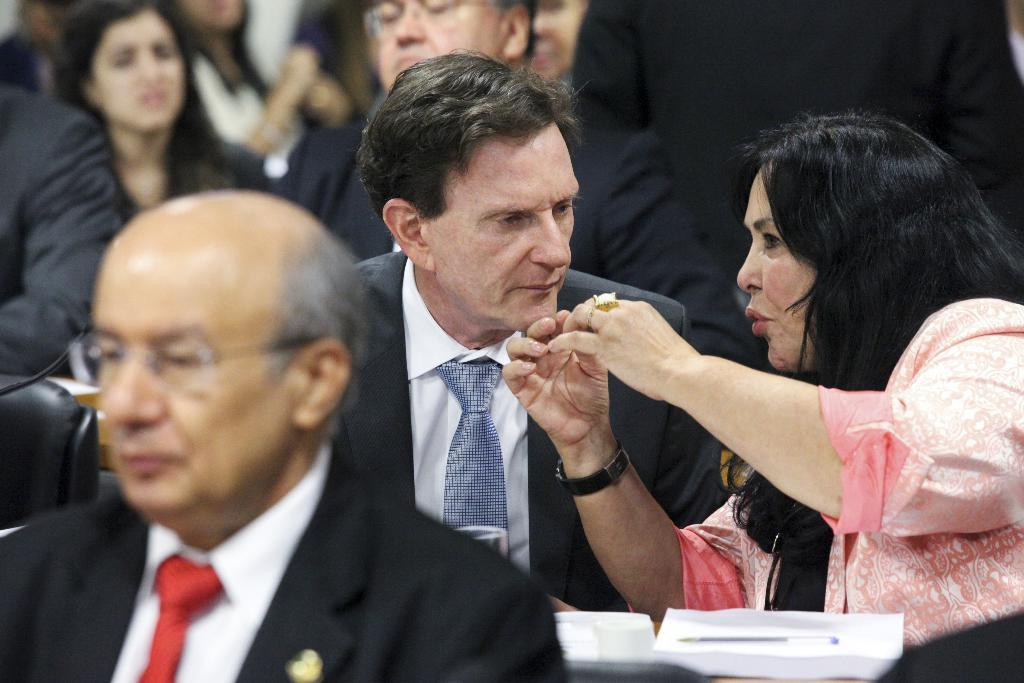What are the people in the image doing? There is a group of people sitting in the image, which suggests they might be engaged in a meeting or discussion. What object is present that might be used for amplifying sound? There is a mic in the image, which could be used for amplifying sound during a presentation or discussion. What items can be seen that might be used for writing or taking notes? There are papers and a pen in the image, which could be used for writing or taking notes. What is on the table in the image? There is a glass on the table in the image. What is the position of the person in the image? There is a person standing in the image, which might indicate they are presenting or leading the discussion. Can you tell me how many cameras are visible in the image? There are no cameras present in the image. What type of limit is being discussed by the group of people in the image? There is no indication in the image that the group of people is discussing any limits. 